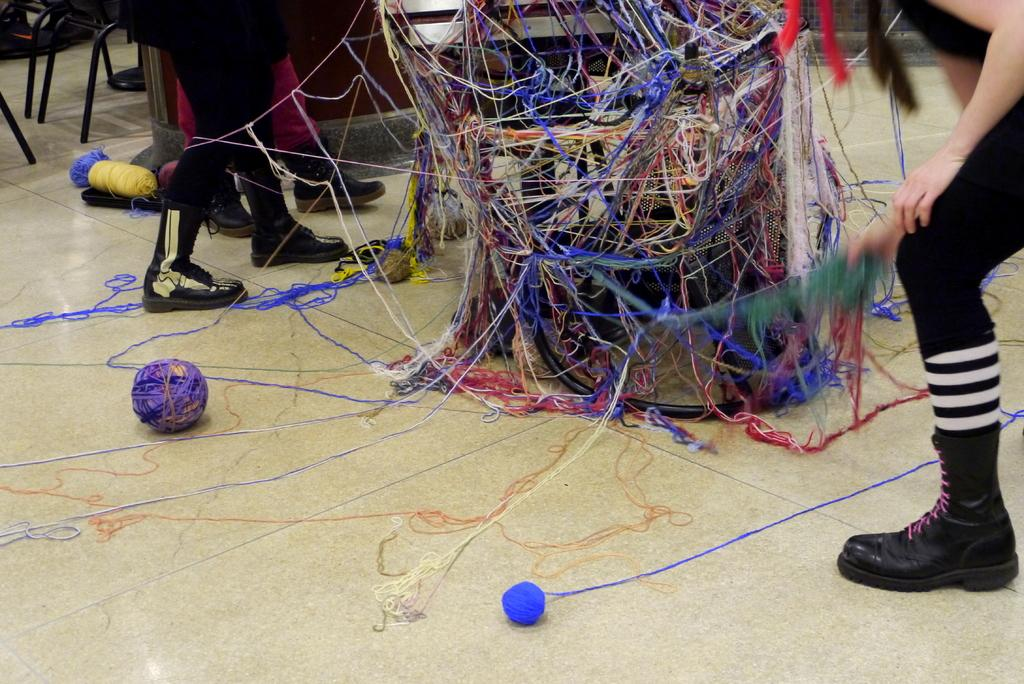What can be seen in the image that belongs to people? There are legs of people visible in the image. What type of objects can be seen in the image that are not related to people? There are woolen balls and chairs in the image. Can you describe any other objects present in the image? There are other objects in the image, but their specific details are not mentioned in the provided facts. What type of bells can be heard ringing in the image? There are no bells present in the image, and therefore no such sound can be heard. What is the view like from the location of the image? The view from the location of the image is not mentioned in the provided facts, so it cannot be determined. 